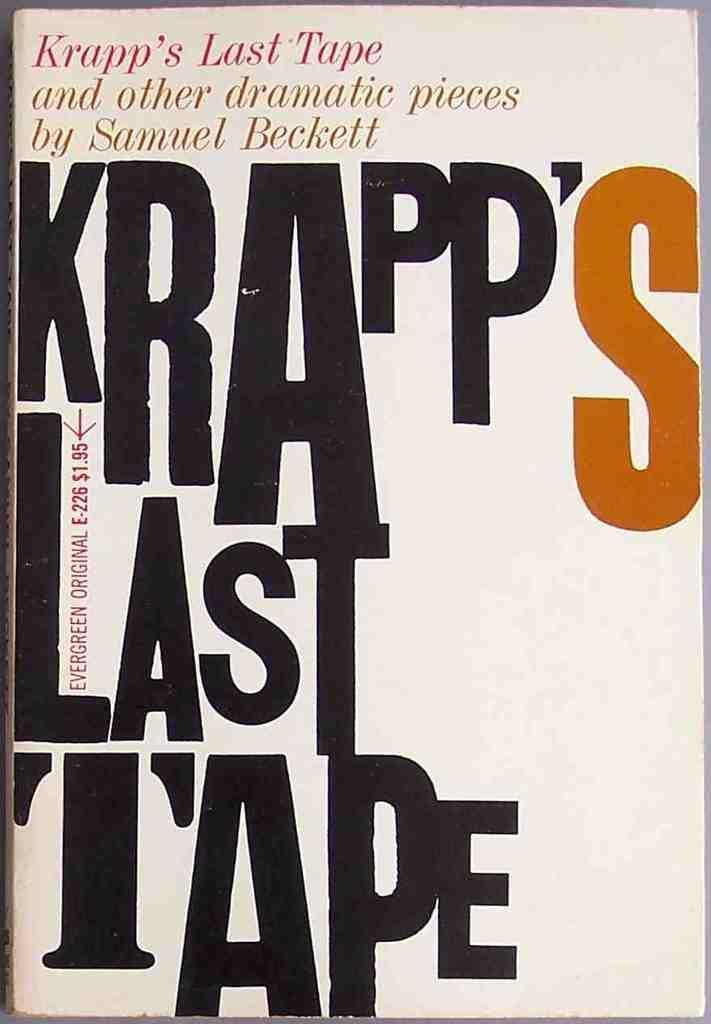Provide a one-sentence caption for the provided image. A collection of Samuel Beckett stories in one book. 